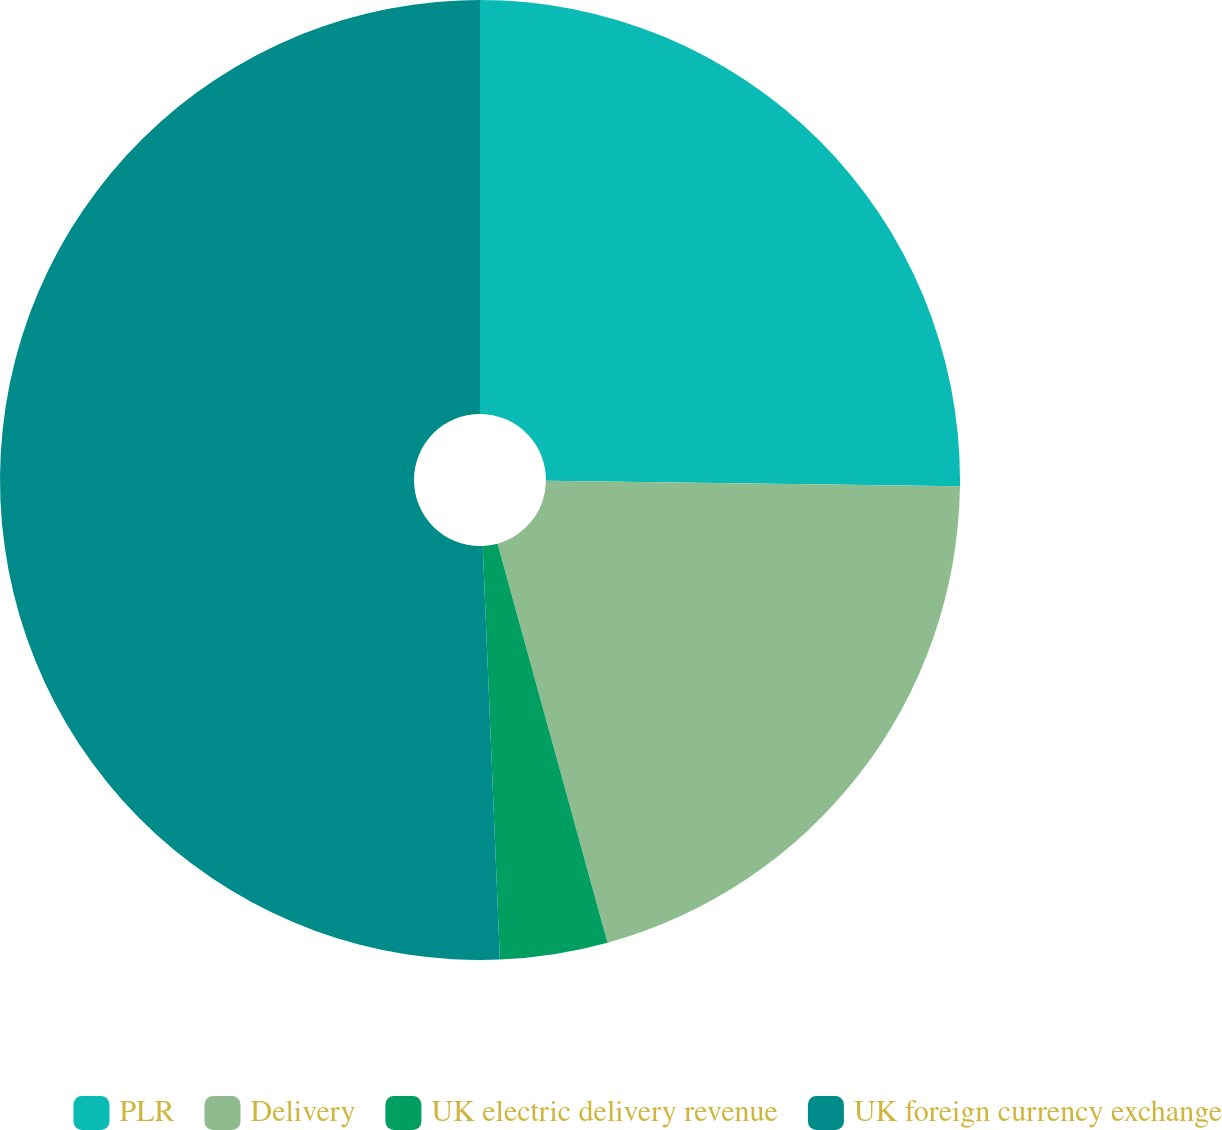Convert chart. <chart><loc_0><loc_0><loc_500><loc_500><pie_chart><fcel>PLR<fcel>Delivery<fcel>UK electric delivery revenue<fcel>UK foreign currency exchange<nl><fcel>25.21%<fcel>20.51%<fcel>3.62%<fcel>50.66%<nl></chart> 